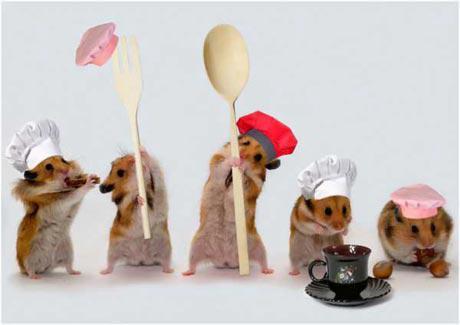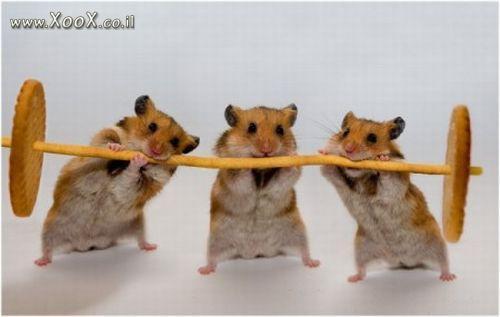The first image is the image on the left, the second image is the image on the right. Given the left and right images, does the statement "There are no more than five tan hamsters in the image on the left." hold true? Answer yes or no. Yes. 